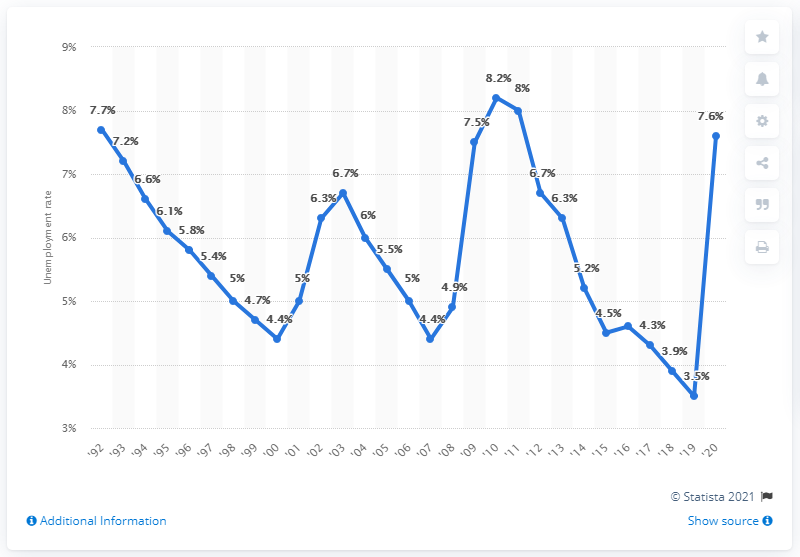Point out several critical features in this image. In 2010, the highest unemployment rate in Texas was 8.2 percent. 